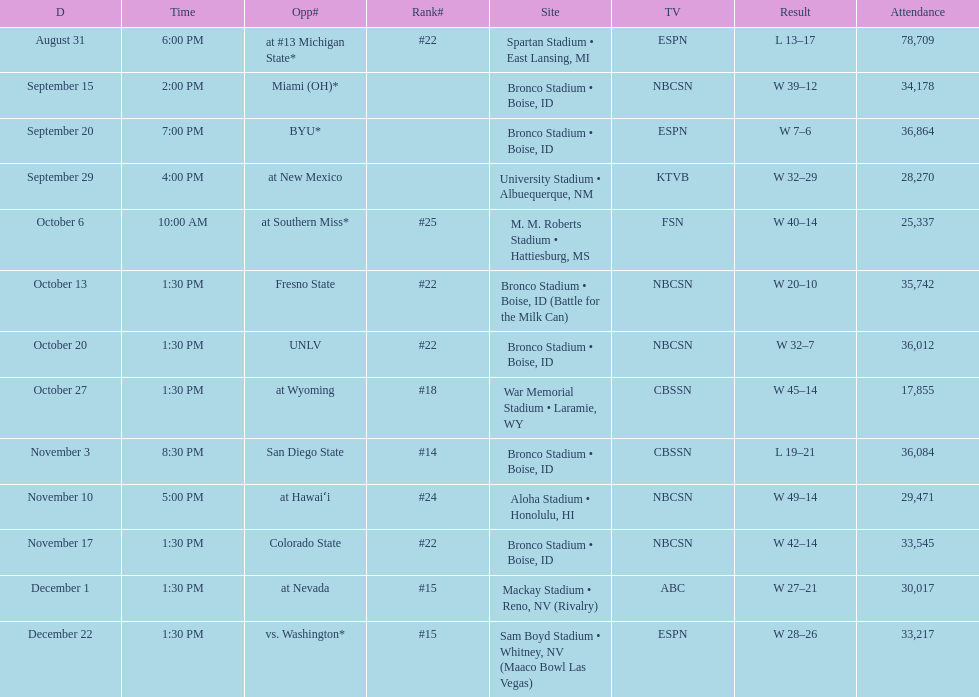Give me the full table as a dictionary. {'header': ['D', 'Time', 'Opp#', 'Rank#', 'Site', 'TV', 'Result', 'Attendance'], 'rows': [['August 31', '6:00 PM', 'at\xa0#13\xa0Michigan State*', '#22', 'Spartan Stadium • East Lansing, MI', 'ESPN', 'L\xa013–17', '78,709'], ['September 15', '2:00 PM', 'Miami (OH)*', '', 'Bronco Stadium • Boise, ID', 'NBCSN', 'W\xa039–12', '34,178'], ['September 20', '7:00 PM', 'BYU*', '', 'Bronco Stadium • Boise, ID', 'ESPN', 'W\xa07–6', '36,864'], ['September 29', '4:00 PM', 'at\xa0New Mexico', '', 'University Stadium • Albuequerque, NM', 'KTVB', 'W\xa032–29', '28,270'], ['October 6', '10:00 AM', 'at\xa0Southern Miss*', '#25', 'M. M. Roberts Stadium • Hattiesburg, MS', 'FSN', 'W\xa040–14', '25,337'], ['October 13', '1:30 PM', 'Fresno State', '#22', 'Bronco Stadium • Boise, ID (Battle for the Milk Can)', 'NBCSN', 'W\xa020–10', '35,742'], ['October 20', '1:30 PM', 'UNLV', '#22', 'Bronco Stadium • Boise, ID', 'NBCSN', 'W\xa032–7', '36,012'], ['October 27', '1:30 PM', 'at\xa0Wyoming', '#18', 'War Memorial Stadium • Laramie, WY', 'CBSSN', 'W\xa045–14', '17,855'], ['November 3', '8:30 PM', 'San Diego State', '#14', 'Bronco Stadium • Boise, ID', 'CBSSN', 'L\xa019–21', '36,084'], ['November 10', '5:00 PM', 'at\xa0Hawaiʻi', '#24', 'Aloha Stadium • Honolulu, HI', 'NBCSN', 'W\xa049–14', '29,471'], ['November 17', '1:30 PM', 'Colorado State', '#22', 'Bronco Stadium • Boise, ID', 'NBCSN', 'W\xa042–14', '33,545'], ['December 1', '1:30 PM', 'at\xa0Nevada', '#15', 'Mackay Stadium • Reno, NV (Rivalry)', 'ABC', 'W\xa027–21', '30,017'], ['December 22', '1:30 PM', 'vs.\xa0Washington*', '#15', 'Sam Boyd Stadium • Whitney, NV (Maaco Bowl Las Vegas)', 'ESPN', 'W\xa028–26', '33,217']]} What rank was boise state after november 10th? #22. 